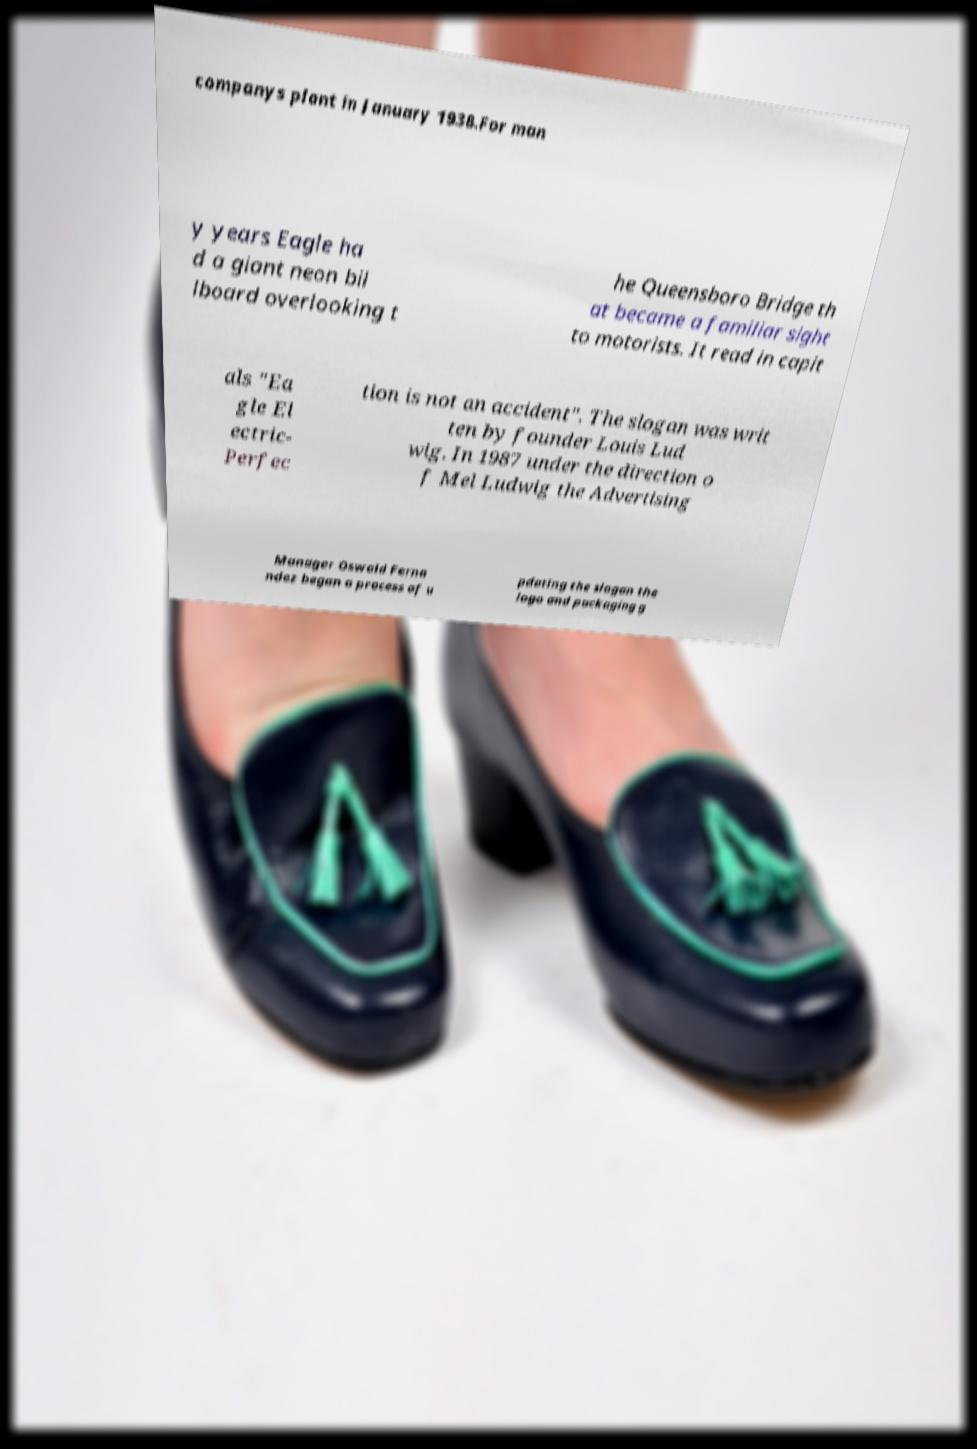Please read and relay the text visible in this image. What does it say? companys plant in January 1938.For man y years Eagle ha d a giant neon bil lboard overlooking t he Queensboro Bridge th at became a familiar sight to motorists. It read in capit als "Ea gle El ectric- Perfec tion is not an accident". The slogan was writ ten by founder Louis Lud wig. In 1987 under the direction o f Mel Ludwig the Advertising Manager Oswald Ferna ndez began a process of u pdating the slogan the logo and packaging g 